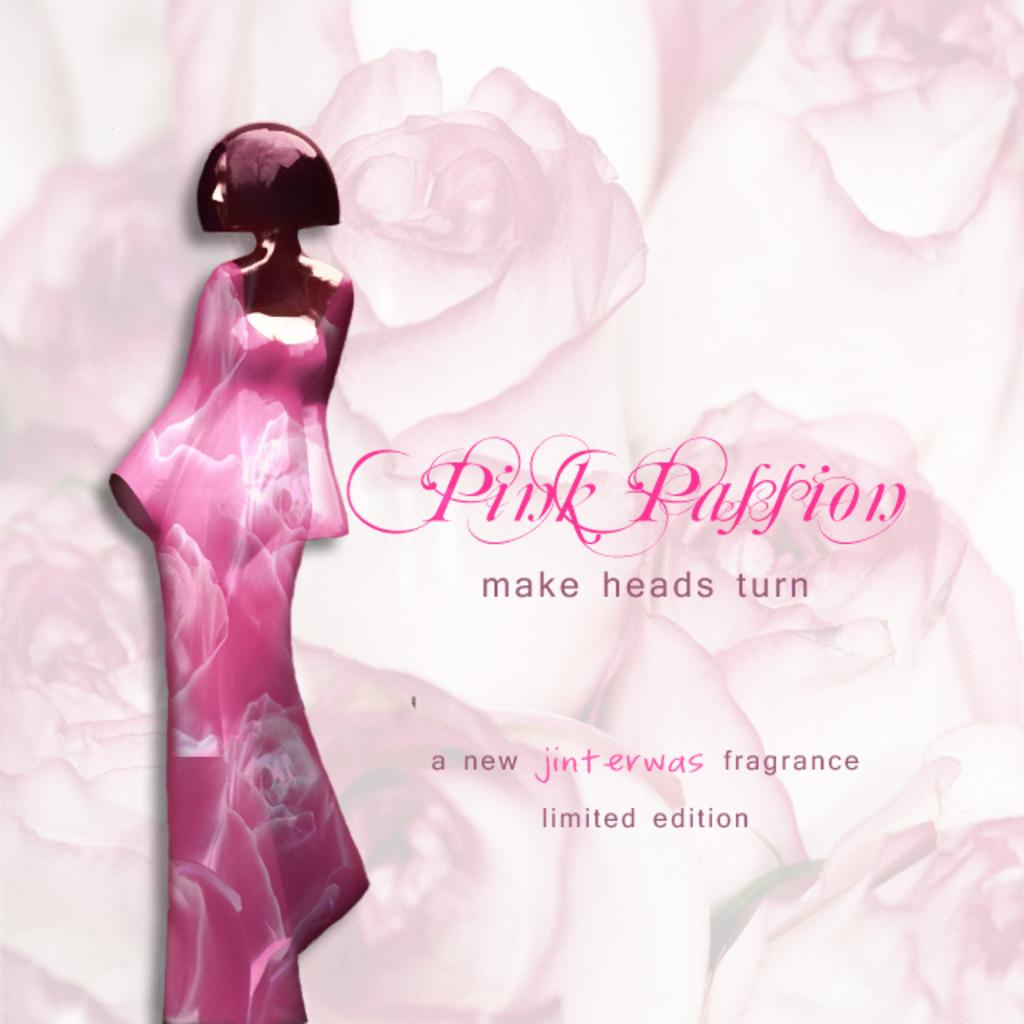What is featured on the poster in the image? The poster contains an image of a lady. Is there any text on the poster? Yes, there is text written on the poster. What can be seen in the background of the image? There are flowers in the background of the image. Is there a tray filled with snow in the image? No, there is no tray or snow present in the image. 